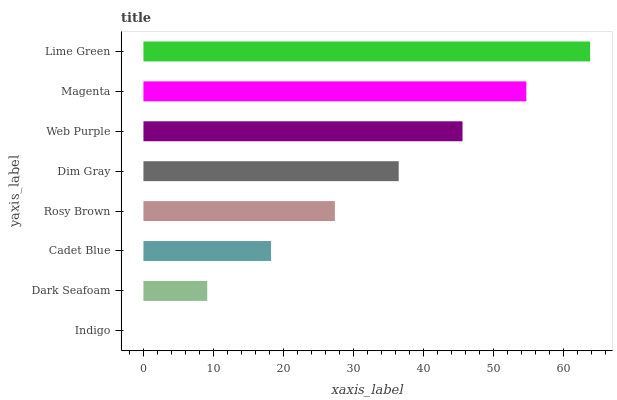Is Indigo the minimum?
Answer yes or no. Yes. Is Lime Green the maximum?
Answer yes or no. Yes. Is Dark Seafoam the minimum?
Answer yes or no. No. Is Dark Seafoam the maximum?
Answer yes or no. No. Is Dark Seafoam greater than Indigo?
Answer yes or no. Yes. Is Indigo less than Dark Seafoam?
Answer yes or no. Yes. Is Indigo greater than Dark Seafoam?
Answer yes or no. No. Is Dark Seafoam less than Indigo?
Answer yes or no. No. Is Dim Gray the high median?
Answer yes or no. Yes. Is Rosy Brown the low median?
Answer yes or no. Yes. Is Indigo the high median?
Answer yes or no. No. Is Indigo the low median?
Answer yes or no. No. 